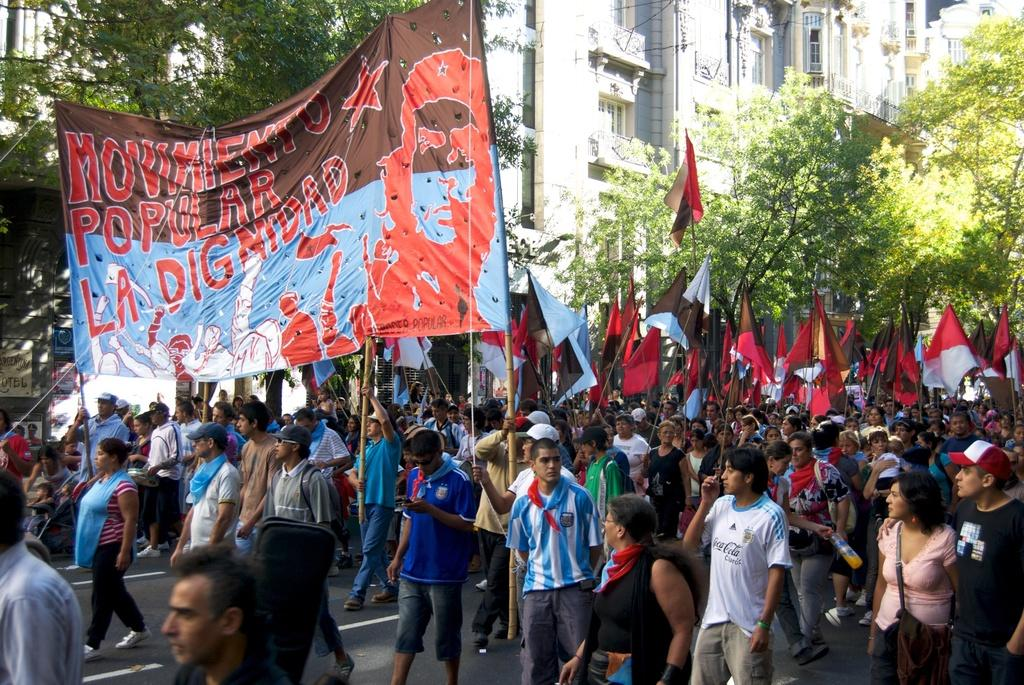What is happening in the image involving the group of people? The people in the image are holding banners and flags. What can be seen on the right side of the image? There are trees on the right side of the image. What is located in the middle of the image? There are buildings in the middle of the image. How many people are kissing in the image? There is no kissing depicted in the image. What color is the cap worn by the person in the image? There is no cap worn by any person in the image. 